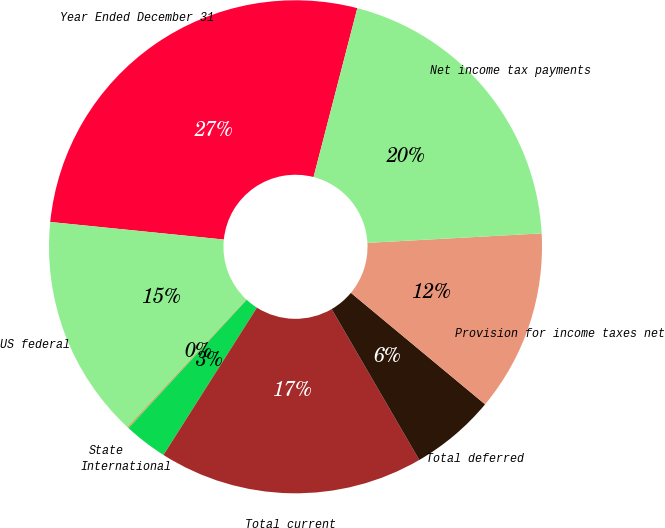<chart> <loc_0><loc_0><loc_500><loc_500><pie_chart><fcel>Year Ended December 31<fcel>US federal<fcel>State<fcel>International<fcel>Total current<fcel>Total deferred<fcel>Provision for income taxes net<fcel>Net income tax payments<nl><fcel>27.43%<fcel>14.64%<fcel>0.12%<fcel>2.85%<fcel>17.37%<fcel>5.59%<fcel>11.9%<fcel>20.1%<nl></chart> 